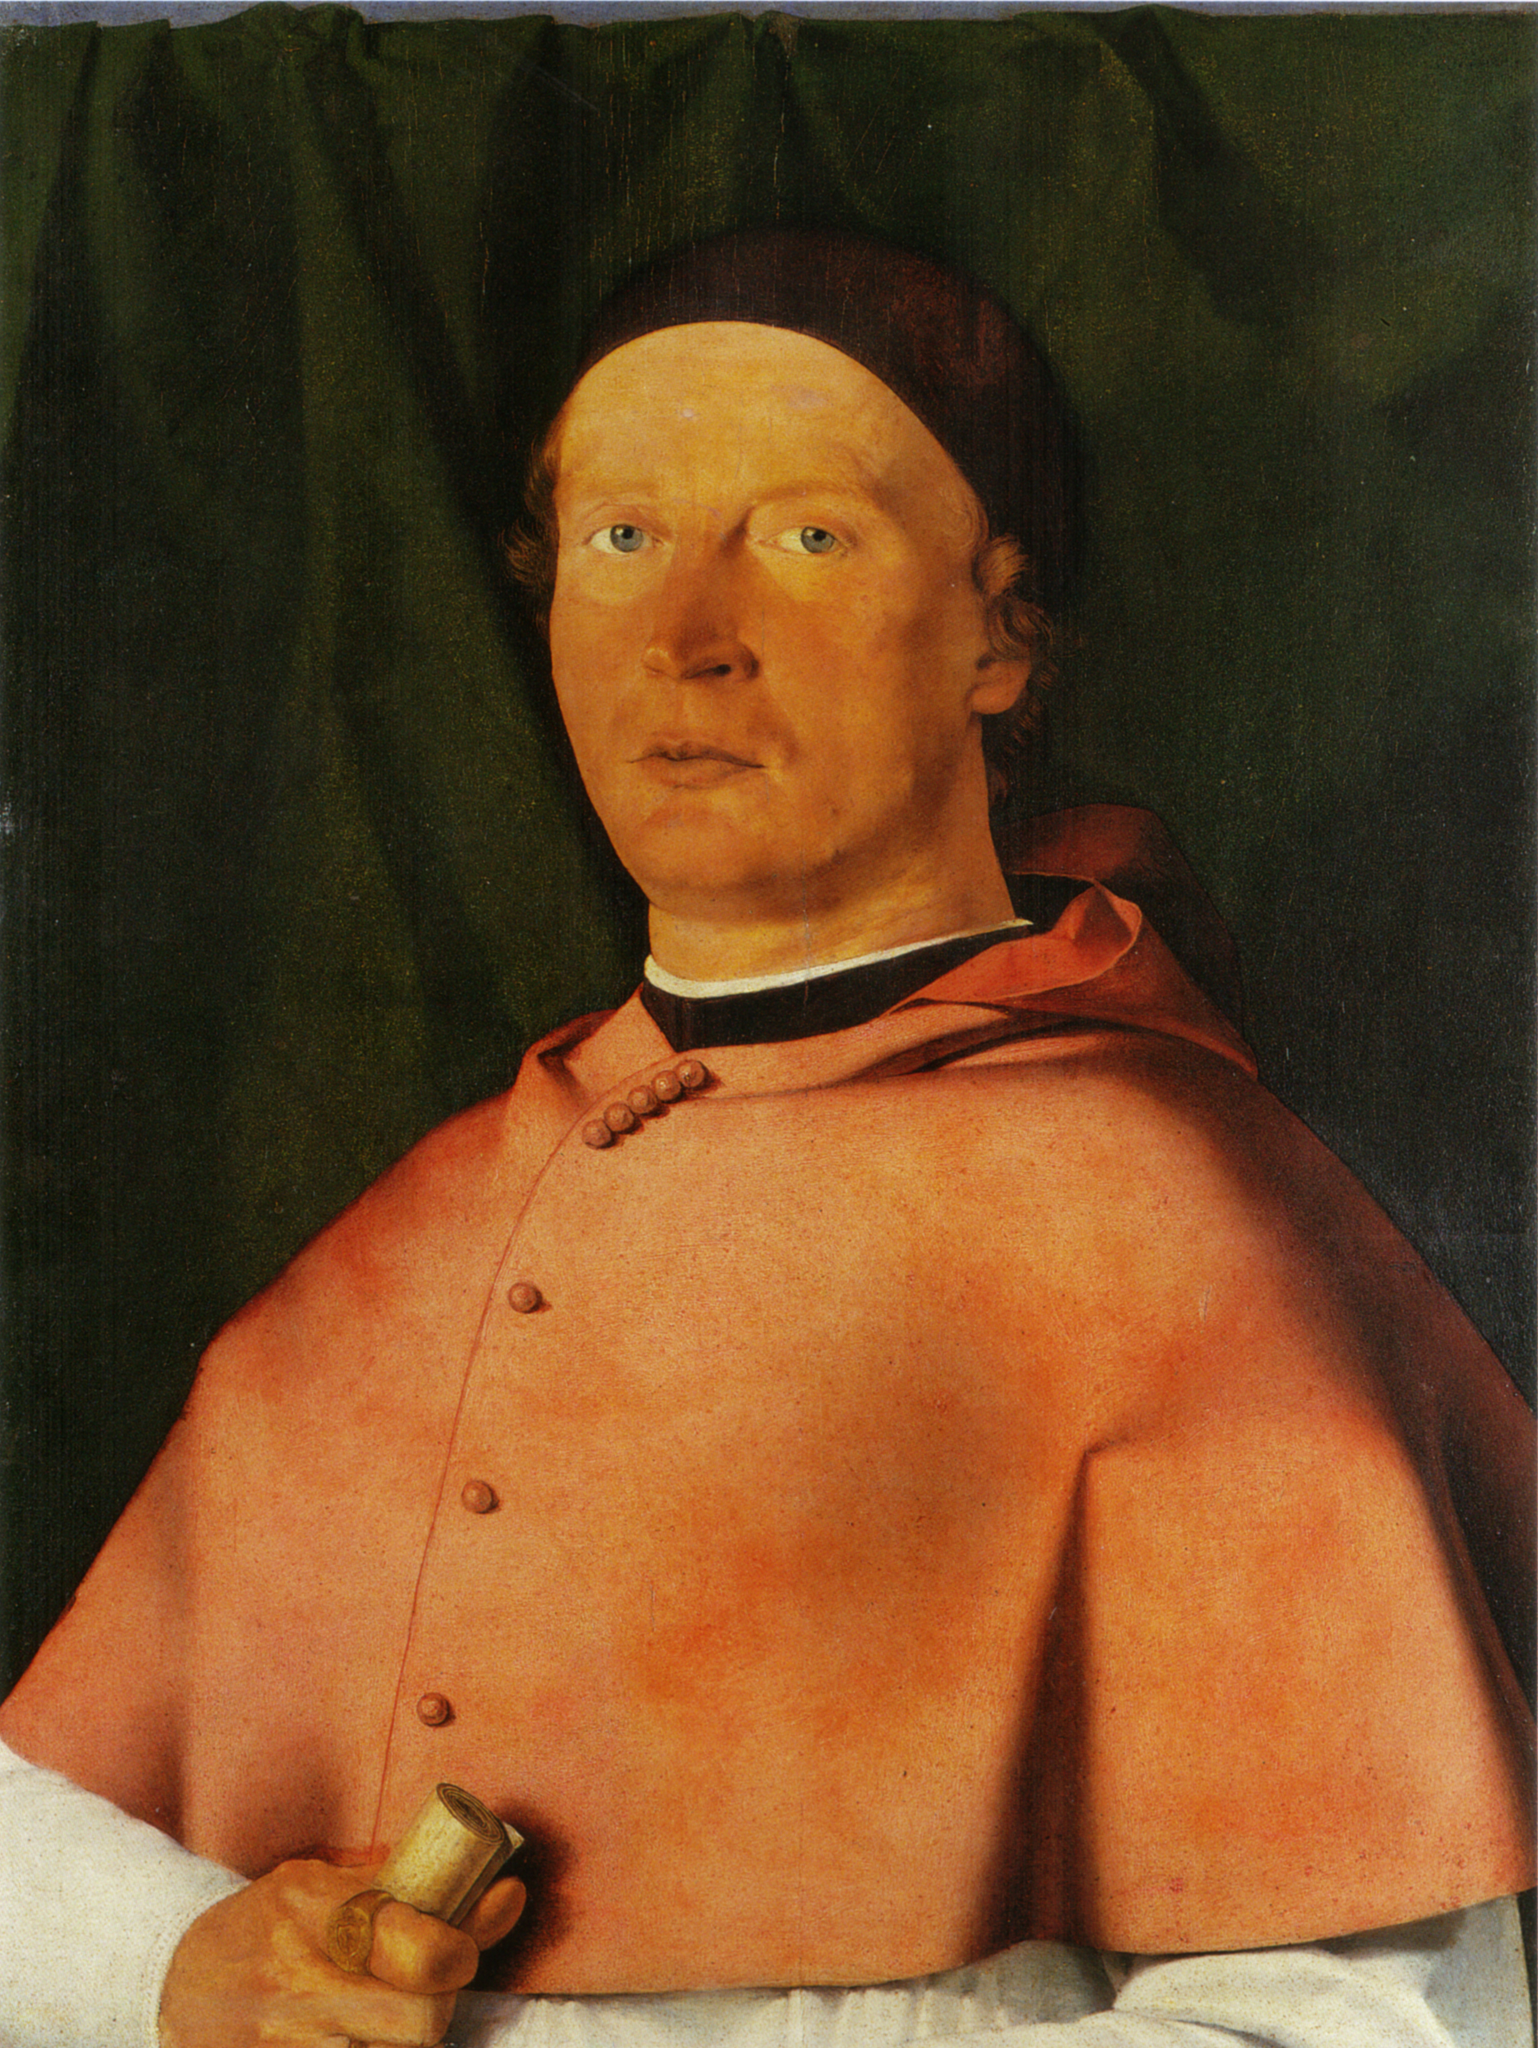If this painting could speak, what story might it tell about the man’s life? The painting opens up a window to a remarkable era in history. It would speak of a devout man dedicated to the service of the people and the quest for knowledge. His disciplined expression and formal attire reflect years of rigorous education and a life spent in pursuit of higher truths. He would share tales of advising royalty, guiding decisions in turbulent times, and the many long nights spent in study, unraveling the mysteries of ancient scrolls. He would speak of honor, duty, and an unwavering commitment to making his world a better place, leaving behind a legacy that history would never forget. 